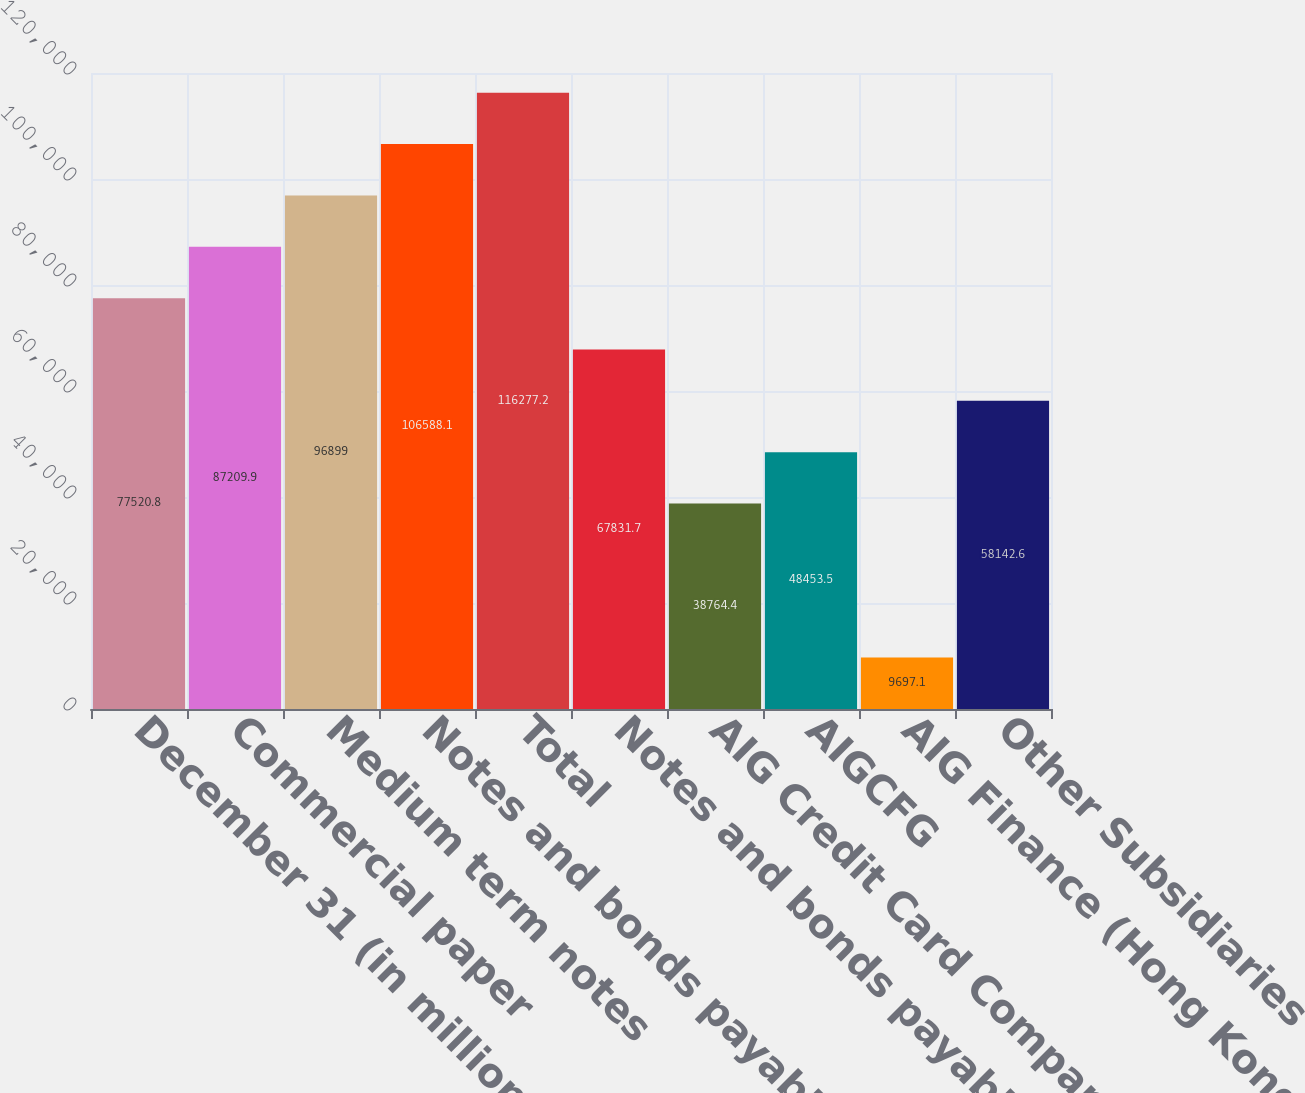Convert chart. <chart><loc_0><loc_0><loc_500><loc_500><bar_chart><fcel>December 31 (in millions)<fcel>Commercial paper<fcel>Medium term notes<fcel>Notes and bonds payable (a)<fcel>Total<fcel>Notes and bonds payable<fcel>AIG Credit Card Company<fcel>AIGCFG<fcel>AIG Finance (Hong Kong)<fcel>Other Subsidiaries<nl><fcel>77520.8<fcel>87209.9<fcel>96899<fcel>106588<fcel>116277<fcel>67831.7<fcel>38764.4<fcel>48453.5<fcel>9697.1<fcel>58142.6<nl></chart> 